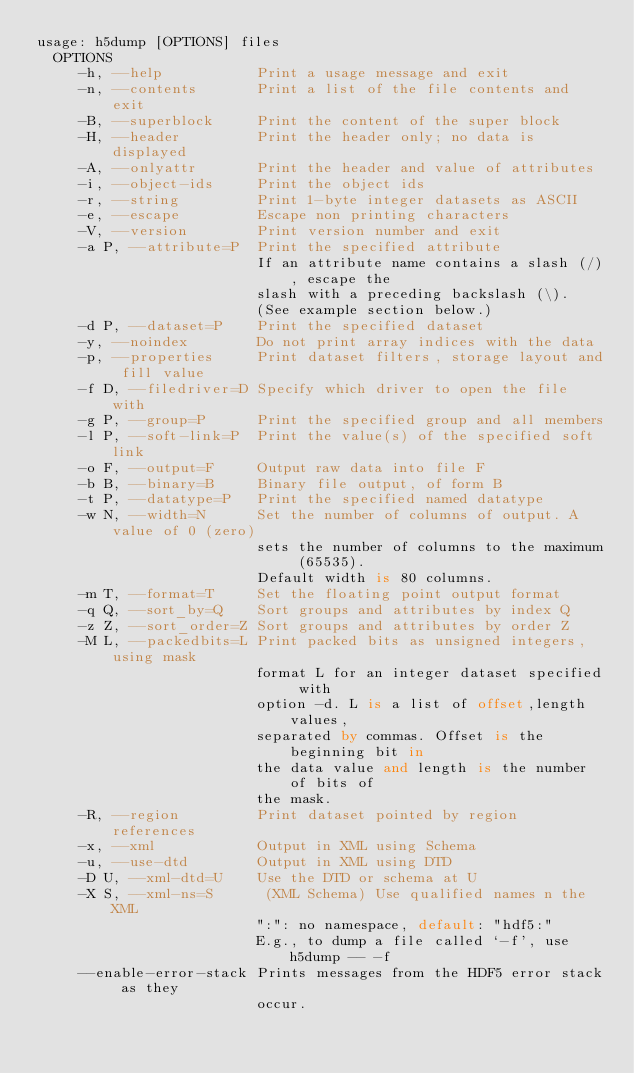Convert code to text. <code><loc_0><loc_0><loc_500><loc_500><_SQL_>usage: h5dump [OPTIONS] files
  OPTIONS
     -h, --help           Print a usage message and exit
     -n, --contents       Print a list of the file contents and exit
     -B, --superblock     Print the content of the super block
     -H, --header         Print the header only; no data is displayed
     -A, --onlyattr       Print the header and value of attributes
     -i, --object-ids     Print the object ids
     -r, --string         Print 1-byte integer datasets as ASCII
     -e, --escape         Escape non printing characters
     -V, --version        Print version number and exit
     -a P, --attribute=P  Print the specified attribute
                          If an attribute name contains a slash (/), escape the
                          slash with a preceding backslash (\).
                          (See example section below.)
     -d P, --dataset=P    Print the specified dataset
     -y, --noindex        Do not print array indices with the data
     -p, --properties     Print dataset filters, storage layout and fill value
     -f D, --filedriver=D Specify which driver to open the file with
     -g P, --group=P      Print the specified group and all members
     -l P, --soft-link=P  Print the value(s) of the specified soft link
     -o F, --output=F     Output raw data into file F
     -b B, --binary=B     Binary file output, of form B
     -t P, --datatype=P   Print the specified named datatype
     -w N, --width=N      Set the number of columns of output. A value of 0 (zero)
                          sets the number of columns to the maximum (65535).
                          Default width is 80 columns.
     -m T, --format=T     Set the floating point output format
     -q Q, --sort_by=Q    Sort groups and attributes by index Q
     -z Z, --sort_order=Z Sort groups and attributes by order Z
     -M L, --packedbits=L Print packed bits as unsigned integers, using mask
                          format L for an integer dataset specified with
                          option -d. L is a list of offset,length values,
                          separated by commas. Offset is the beginning bit in
                          the data value and length is the number of bits of
                          the mask.
     -R, --region         Print dataset pointed by region references
     -x, --xml            Output in XML using Schema
     -u, --use-dtd        Output in XML using DTD
     -D U, --xml-dtd=U    Use the DTD or schema at U
     -X S, --xml-ns=S      (XML Schema) Use qualified names n the XML
                          ":": no namespace, default: "hdf5:"
                          E.g., to dump a file called `-f', use h5dump -- -f
     --enable-error-stack Prints messages from the HDF5 error stack as they
                          occur.</code> 